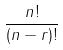<formula> <loc_0><loc_0><loc_500><loc_500>\frac { n ! } { ( n - r ) ! }</formula> 